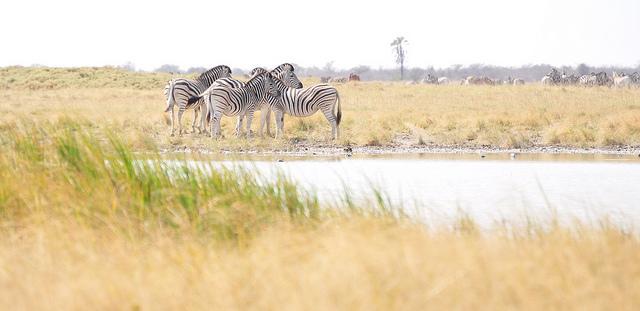What animals are shown?
Short answer required. Zebras. Are these wild or domesticated animals?
Answer briefly. Wild. What color are the zebras?
Be succinct. Black and white. How many zebras are drinking?
Be succinct. 0. Where is the grass?
Short answer required. Around water. 